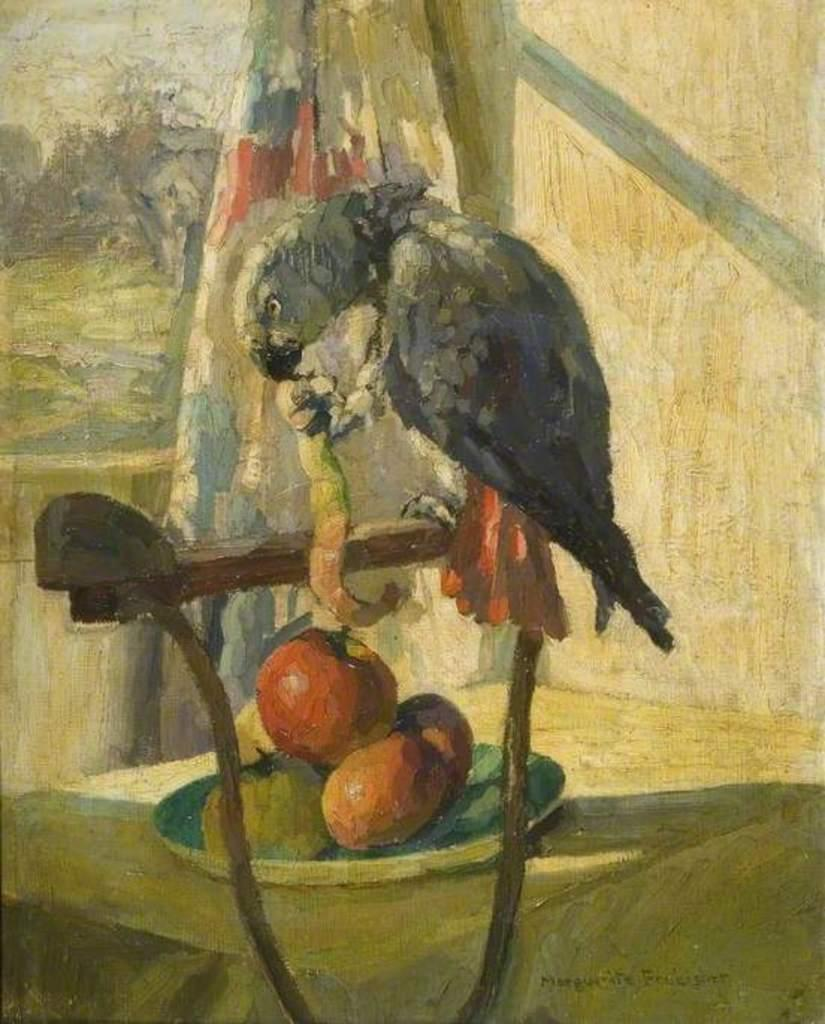What is depicted in the painting that is visible in the image? There is a painting of a bird in the image. How is the painting displayed in the image? The painting is on a stand. What type of food can be seen in the image? There are fruits in a plate in the image. Where is the plate with fruits located in the image? The plate is placed on a table. What rule is being enforced by the bird in the painting? There is no rule being enforced by the bird in the painting, as it is a static image and not an active participant in any scenario. 